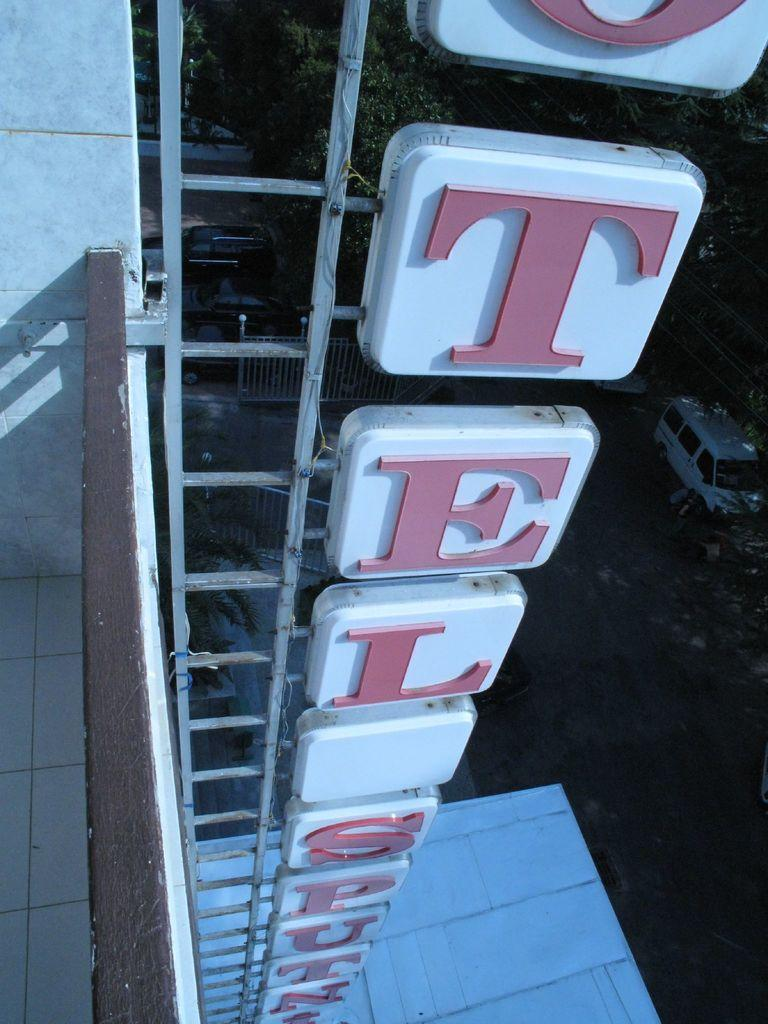What is the main object featured in the image? There is a naming board with a frame in the image. Where is the naming board located? The naming board is placed on a building. What else can be seen on the ground in the image? There is a white van parked on the ground in the image. What can be seen in the distance in the image? Trees are visible in the background of the image. How many worms can be seen crawling on the naming board in the image? There are no worms present in the image; the naming board is on a building with a frame. What type of oven is visible in the image? There is no oven present in the image. 